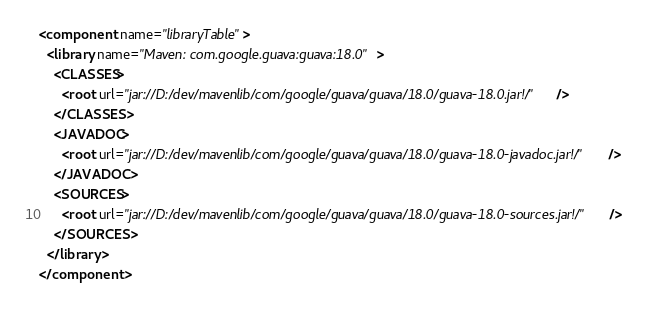Convert code to text. <code><loc_0><loc_0><loc_500><loc_500><_XML_><component name="libraryTable">
  <library name="Maven: com.google.guava:guava:18.0">
    <CLASSES>
      <root url="jar://D:/dev/mavenlib/com/google/guava/guava/18.0/guava-18.0.jar!/" />
    </CLASSES>
    <JAVADOC>
      <root url="jar://D:/dev/mavenlib/com/google/guava/guava/18.0/guava-18.0-javadoc.jar!/" />
    </JAVADOC>
    <SOURCES>
      <root url="jar://D:/dev/mavenlib/com/google/guava/guava/18.0/guava-18.0-sources.jar!/" />
    </SOURCES>
  </library>
</component></code> 